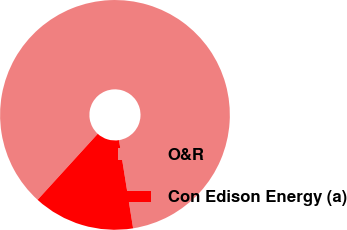<chart> <loc_0><loc_0><loc_500><loc_500><pie_chart><fcel>O&R<fcel>Con Edison Energy (a)<nl><fcel>85.71%<fcel>14.29%<nl></chart> 